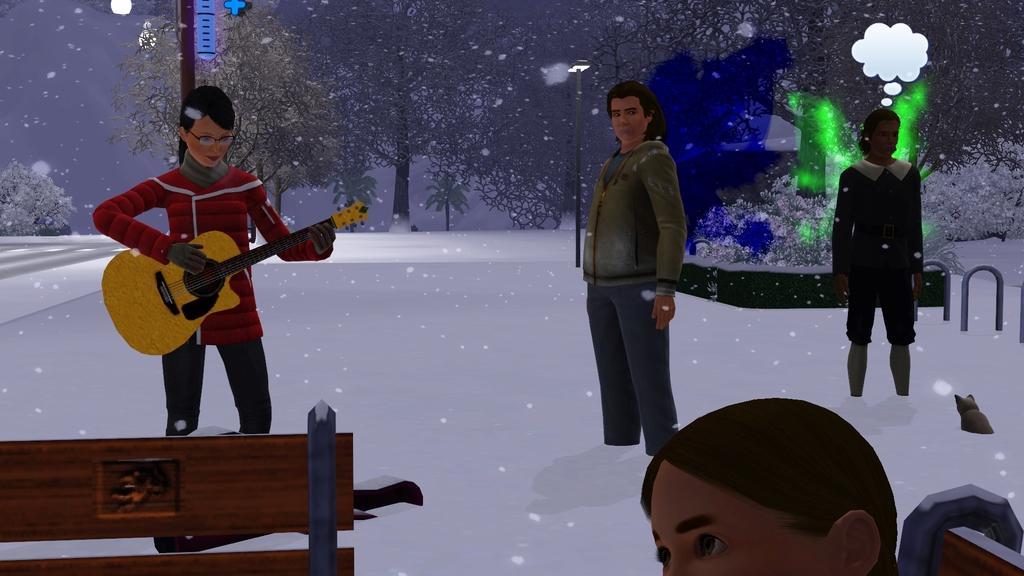Could you give a brief overview of what you see in this image? In this picture there is a woman wearing red dress is standing in the snow and playing guitar and there are two other persons beside her and there is an animal and a person in the right corner and there are trees covered with snow in the background. 